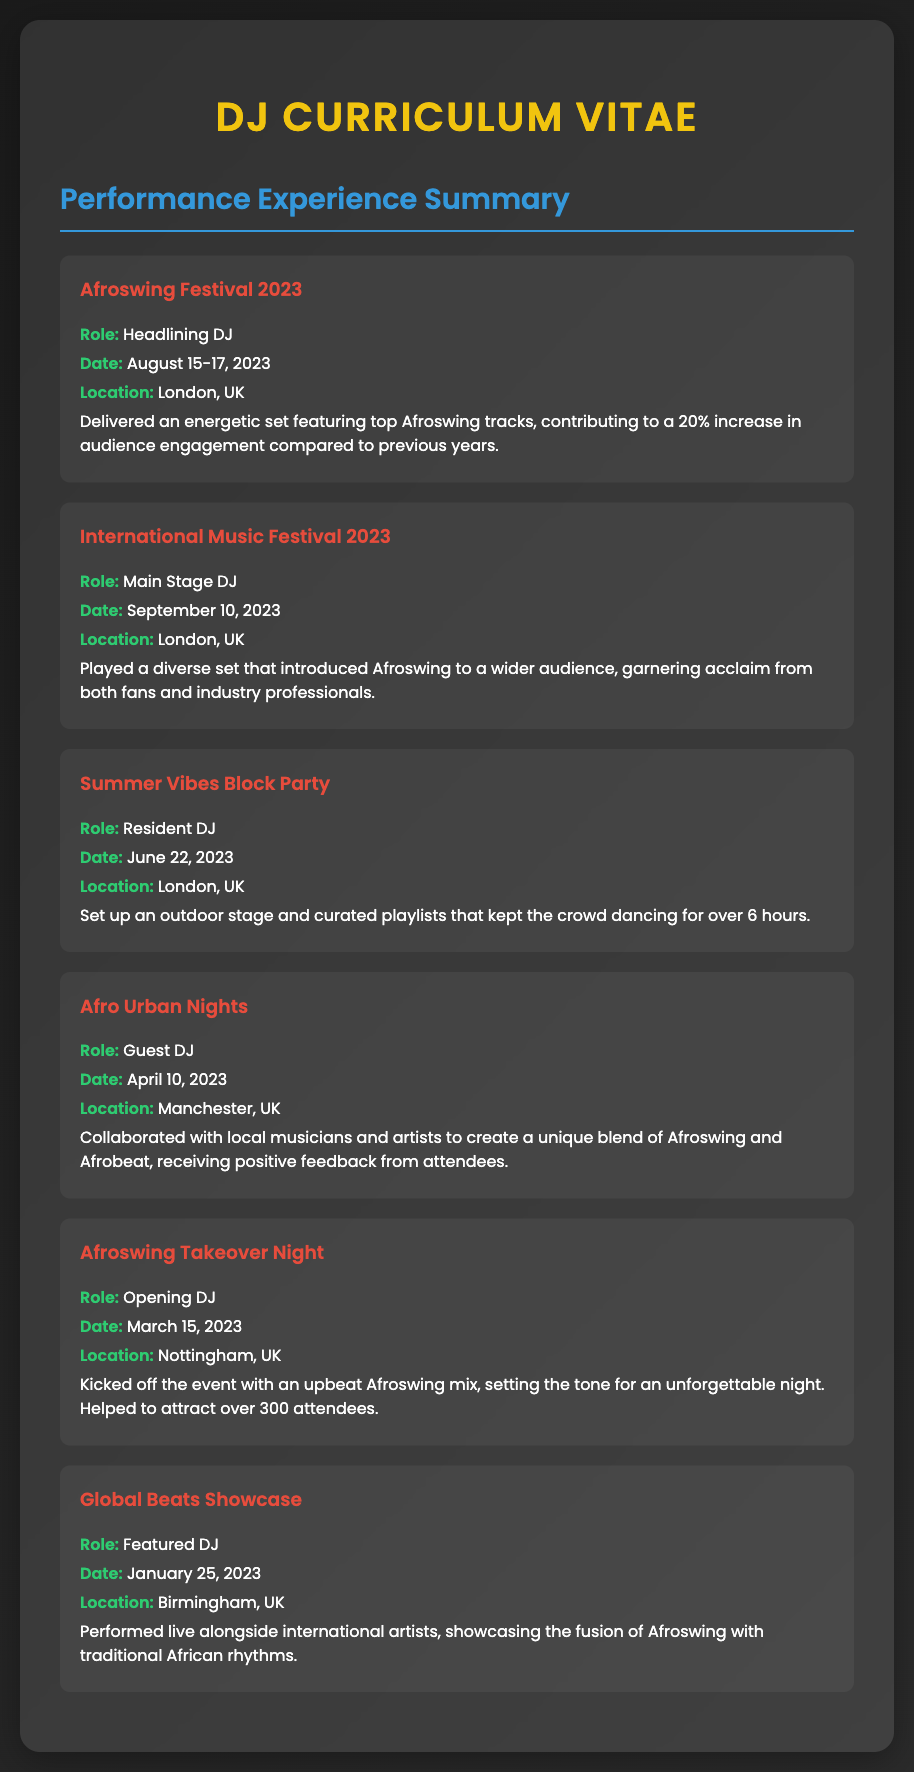What is the role of the DJ at the Afroswing Festival 2023? The role at the Afroswing Festival 2023 is specified in the document as "Headlining DJ".
Answer: Headlining DJ When was the International Music Festival 2023 held? The date for the International Music Festival 2023 is mentioned in the document as September 10, 2023.
Answer: September 10, 2023 Where did the Summer Vibes Block Party take place? The location for the Summer Vibes Block Party is provided in the document as London, UK.
Answer: London, UK How long did the crowd dance at the Summer Vibes Block Party? The document states that the crowd danced for over 6 hours during the Summer Vibes Block Party.
Answer: Over 6 hours What was the estimated audience increase at the Afroswing Festival 2023? The document notes a 20% increase in audience engagement at the Afroswing Festival 2023 compared to previous years.
Answer: 20% Which event had the role of Opening DJ? The document specifies that the Afroswing Takeover Night had the role of Opening DJ.
Answer: Afroswing Takeover Night Who collaborated with local musicians during Afro Urban Nights? The document mentions that the DJ served as a "Guest DJ" at Afro Urban Nights.
Answer: Guest DJ What type of music was showcased at the Global Beats Showcase? The document states that the fusion of Afroswing with traditional African rhythms was performed at the Global Beats Showcase.
Answer: Afroswing with traditional African rhythms 